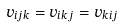<formula> <loc_0><loc_0><loc_500><loc_500>v _ { i j k } = v _ { i k j } = v _ { k i j }</formula> 